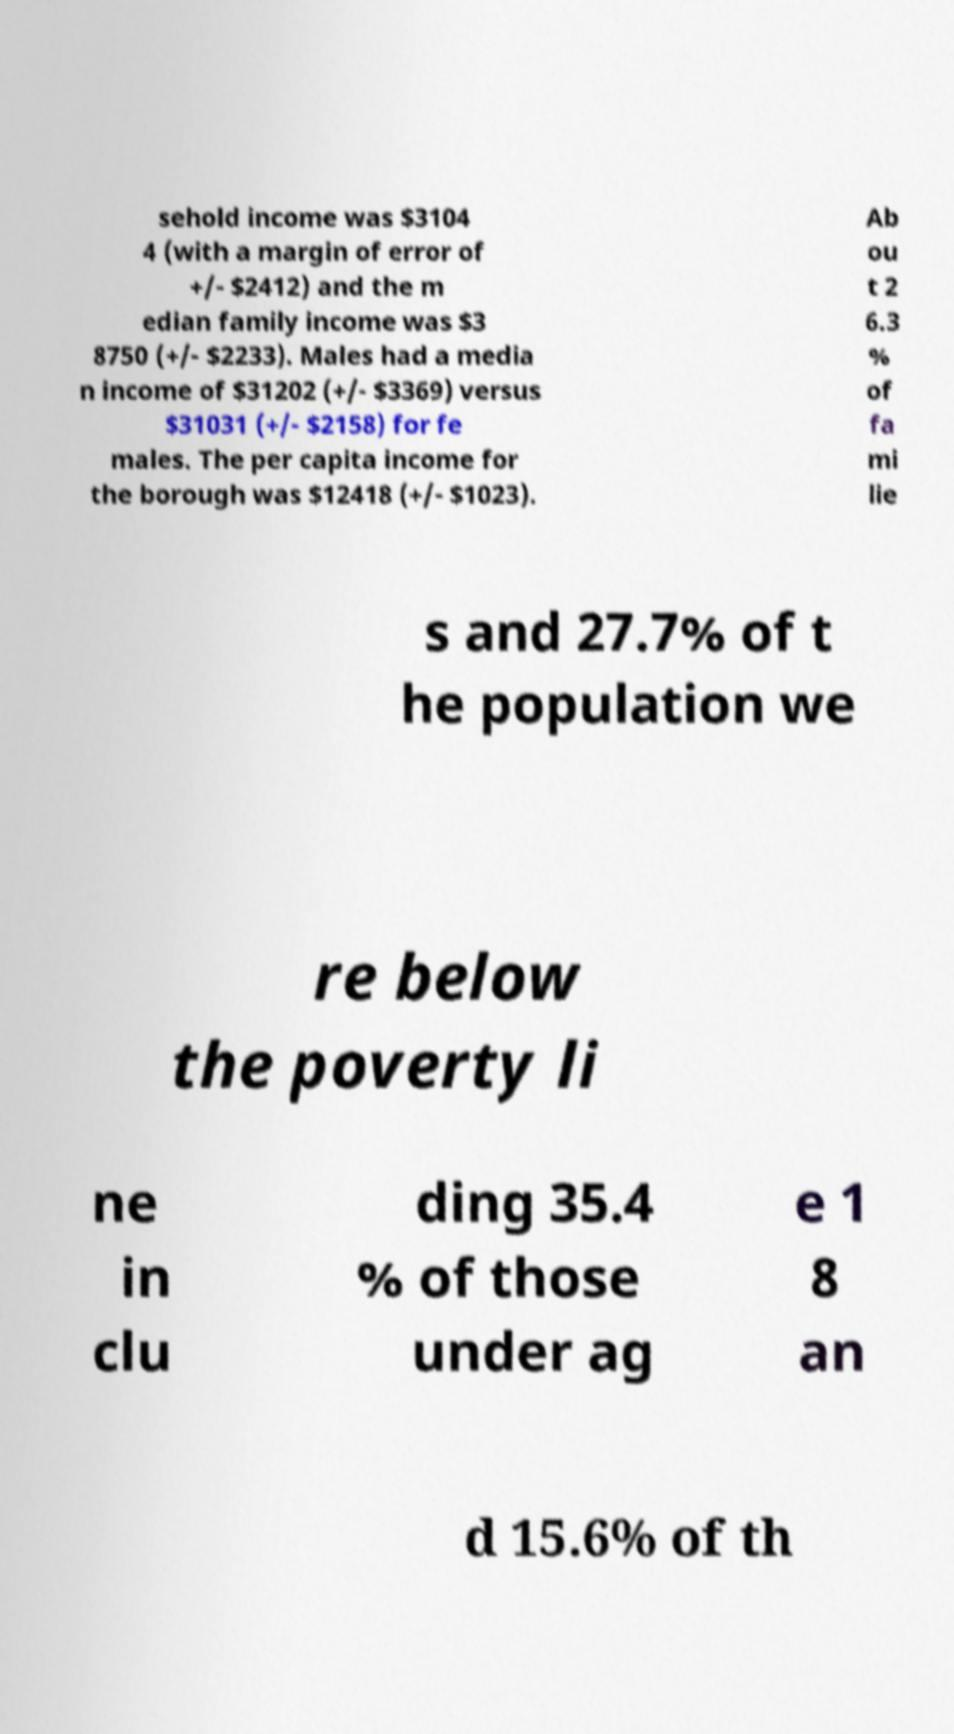Could you assist in decoding the text presented in this image and type it out clearly? sehold income was $3104 4 (with a margin of error of +/- $2412) and the m edian family income was $3 8750 (+/- $2233). Males had a media n income of $31202 (+/- $3369) versus $31031 (+/- $2158) for fe males. The per capita income for the borough was $12418 (+/- $1023). Ab ou t 2 6.3 % of fa mi lie s and 27.7% of t he population we re below the poverty li ne in clu ding 35.4 % of those under ag e 1 8 an d 15.6% of th 